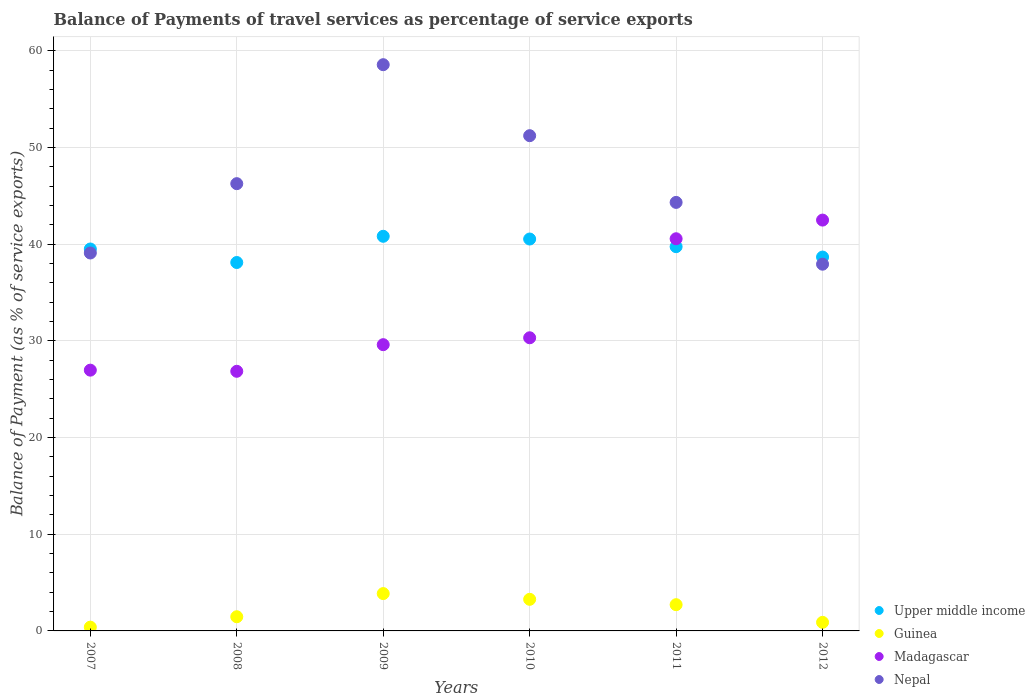What is the balance of payments of travel services in Madagascar in 2011?
Offer a terse response. 40.56. Across all years, what is the maximum balance of payments of travel services in Nepal?
Your response must be concise. 58.57. Across all years, what is the minimum balance of payments of travel services in Guinea?
Provide a succinct answer. 0.39. In which year was the balance of payments of travel services in Nepal maximum?
Your response must be concise. 2009. What is the total balance of payments of travel services in Upper middle income in the graph?
Provide a short and direct response. 237.39. What is the difference between the balance of payments of travel services in Upper middle income in 2010 and that in 2012?
Ensure brevity in your answer.  1.87. What is the difference between the balance of payments of travel services in Upper middle income in 2007 and the balance of payments of travel services in Madagascar in 2008?
Give a very brief answer. 12.65. What is the average balance of payments of travel services in Madagascar per year?
Give a very brief answer. 32.8. In the year 2010, what is the difference between the balance of payments of travel services in Guinea and balance of payments of travel services in Madagascar?
Give a very brief answer. -27.05. What is the ratio of the balance of payments of travel services in Madagascar in 2007 to that in 2009?
Provide a succinct answer. 0.91. Is the balance of payments of travel services in Madagascar in 2011 less than that in 2012?
Your answer should be very brief. Yes. Is the difference between the balance of payments of travel services in Guinea in 2008 and 2009 greater than the difference between the balance of payments of travel services in Madagascar in 2008 and 2009?
Give a very brief answer. Yes. What is the difference between the highest and the second highest balance of payments of travel services in Madagascar?
Provide a short and direct response. 1.93. What is the difference between the highest and the lowest balance of payments of travel services in Upper middle income?
Your answer should be very brief. 2.71. Is the sum of the balance of payments of travel services in Guinea in 2009 and 2012 greater than the maximum balance of payments of travel services in Nepal across all years?
Provide a succinct answer. No. Is it the case that in every year, the sum of the balance of payments of travel services in Upper middle income and balance of payments of travel services in Nepal  is greater than the sum of balance of payments of travel services in Guinea and balance of payments of travel services in Madagascar?
Your answer should be very brief. Yes. How many dotlines are there?
Provide a short and direct response. 4. How many years are there in the graph?
Ensure brevity in your answer.  6. Are the values on the major ticks of Y-axis written in scientific E-notation?
Your response must be concise. No. Does the graph contain grids?
Ensure brevity in your answer.  Yes. What is the title of the graph?
Your response must be concise. Balance of Payments of travel services as percentage of service exports. Does "Qatar" appear as one of the legend labels in the graph?
Ensure brevity in your answer.  No. What is the label or title of the X-axis?
Your answer should be very brief. Years. What is the label or title of the Y-axis?
Provide a succinct answer. Balance of Payment (as % of service exports). What is the Balance of Payment (as % of service exports) of Upper middle income in 2007?
Your answer should be compact. 39.51. What is the Balance of Payment (as % of service exports) in Guinea in 2007?
Give a very brief answer. 0.39. What is the Balance of Payment (as % of service exports) in Madagascar in 2007?
Give a very brief answer. 26.97. What is the Balance of Payment (as % of service exports) of Nepal in 2007?
Make the answer very short. 39.09. What is the Balance of Payment (as % of service exports) in Upper middle income in 2008?
Make the answer very short. 38.11. What is the Balance of Payment (as % of service exports) of Guinea in 2008?
Offer a terse response. 1.47. What is the Balance of Payment (as % of service exports) of Madagascar in 2008?
Keep it short and to the point. 26.86. What is the Balance of Payment (as % of service exports) of Nepal in 2008?
Keep it short and to the point. 46.26. What is the Balance of Payment (as % of service exports) in Upper middle income in 2009?
Your answer should be compact. 40.82. What is the Balance of Payment (as % of service exports) in Guinea in 2009?
Provide a short and direct response. 3.86. What is the Balance of Payment (as % of service exports) in Madagascar in 2009?
Offer a terse response. 29.61. What is the Balance of Payment (as % of service exports) in Nepal in 2009?
Provide a short and direct response. 58.57. What is the Balance of Payment (as % of service exports) of Upper middle income in 2010?
Provide a short and direct response. 40.54. What is the Balance of Payment (as % of service exports) of Guinea in 2010?
Offer a very short reply. 3.27. What is the Balance of Payment (as % of service exports) in Madagascar in 2010?
Give a very brief answer. 30.32. What is the Balance of Payment (as % of service exports) in Nepal in 2010?
Make the answer very short. 51.23. What is the Balance of Payment (as % of service exports) of Upper middle income in 2011?
Provide a succinct answer. 39.75. What is the Balance of Payment (as % of service exports) of Guinea in 2011?
Your answer should be compact. 2.71. What is the Balance of Payment (as % of service exports) of Madagascar in 2011?
Your answer should be very brief. 40.56. What is the Balance of Payment (as % of service exports) in Nepal in 2011?
Give a very brief answer. 44.33. What is the Balance of Payment (as % of service exports) in Upper middle income in 2012?
Your answer should be compact. 38.67. What is the Balance of Payment (as % of service exports) in Guinea in 2012?
Your answer should be compact. 0.89. What is the Balance of Payment (as % of service exports) of Madagascar in 2012?
Provide a succinct answer. 42.5. What is the Balance of Payment (as % of service exports) of Nepal in 2012?
Your response must be concise. 37.93. Across all years, what is the maximum Balance of Payment (as % of service exports) of Upper middle income?
Your response must be concise. 40.82. Across all years, what is the maximum Balance of Payment (as % of service exports) in Guinea?
Make the answer very short. 3.86. Across all years, what is the maximum Balance of Payment (as % of service exports) in Madagascar?
Your response must be concise. 42.5. Across all years, what is the maximum Balance of Payment (as % of service exports) in Nepal?
Offer a terse response. 58.57. Across all years, what is the minimum Balance of Payment (as % of service exports) in Upper middle income?
Provide a short and direct response. 38.11. Across all years, what is the minimum Balance of Payment (as % of service exports) of Guinea?
Provide a succinct answer. 0.39. Across all years, what is the minimum Balance of Payment (as % of service exports) of Madagascar?
Make the answer very short. 26.86. Across all years, what is the minimum Balance of Payment (as % of service exports) of Nepal?
Provide a short and direct response. 37.93. What is the total Balance of Payment (as % of service exports) in Upper middle income in the graph?
Provide a succinct answer. 237.39. What is the total Balance of Payment (as % of service exports) of Guinea in the graph?
Offer a terse response. 12.59. What is the total Balance of Payment (as % of service exports) of Madagascar in the graph?
Provide a succinct answer. 196.82. What is the total Balance of Payment (as % of service exports) in Nepal in the graph?
Provide a short and direct response. 277.41. What is the difference between the Balance of Payment (as % of service exports) of Upper middle income in 2007 and that in 2008?
Your response must be concise. 1.4. What is the difference between the Balance of Payment (as % of service exports) in Guinea in 2007 and that in 2008?
Your answer should be compact. -1.08. What is the difference between the Balance of Payment (as % of service exports) in Madagascar in 2007 and that in 2008?
Make the answer very short. 0.12. What is the difference between the Balance of Payment (as % of service exports) in Nepal in 2007 and that in 2008?
Provide a succinct answer. -7.17. What is the difference between the Balance of Payment (as % of service exports) in Upper middle income in 2007 and that in 2009?
Give a very brief answer. -1.31. What is the difference between the Balance of Payment (as % of service exports) in Guinea in 2007 and that in 2009?
Provide a short and direct response. -3.47. What is the difference between the Balance of Payment (as % of service exports) in Madagascar in 2007 and that in 2009?
Provide a short and direct response. -2.64. What is the difference between the Balance of Payment (as % of service exports) in Nepal in 2007 and that in 2009?
Offer a very short reply. -19.48. What is the difference between the Balance of Payment (as % of service exports) in Upper middle income in 2007 and that in 2010?
Your answer should be compact. -1.03. What is the difference between the Balance of Payment (as % of service exports) of Guinea in 2007 and that in 2010?
Give a very brief answer. -2.88. What is the difference between the Balance of Payment (as % of service exports) in Madagascar in 2007 and that in 2010?
Offer a terse response. -3.35. What is the difference between the Balance of Payment (as % of service exports) in Nepal in 2007 and that in 2010?
Make the answer very short. -12.13. What is the difference between the Balance of Payment (as % of service exports) in Upper middle income in 2007 and that in 2011?
Ensure brevity in your answer.  -0.24. What is the difference between the Balance of Payment (as % of service exports) in Guinea in 2007 and that in 2011?
Give a very brief answer. -2.32. What is the difference between the Balance of Payment (as % of service exports) in Madagascar in 2007 and that in 2011?
Provide a succinct answer. -13.59. What is the difference between the Balance of Payment (as % of service exports) in Nepal in 2007 and that in 2011?
Provide a succinct answer. -5.23. What is the difference between the Balance of Payment (as % of service exports) of Upper middle income in 2007 and that in 2012?
Make the answer very short. 0.83. What is the difference between the Balance of Payment (as % of service exports) of Guinea in 2007 and that in 2012?
Offer a terse response. -0.5. What is the difference between the Balance of Payment (as % of service exports) in Madagascar in 2007 and that in 2012?
Provide a succinct answer. -15.52. What is the difference between the Balance of Payment (as % of service exports) of Nepal in 2007 and that in 2012?
Offer a very short reply. 1.16. What is the difference between the Balance of Payment (as % of service exports) of Upper middle income in 2008 and that in 2009?
Offer a terse response. -2.71. What is the difference between the Balance of Payment (as % of service exports) in Guinea in 2008 and that in 2009?
Ensure brevity in your answer.  -2.39. What is the difference between the Balance of Payment (as % of service exports) in Madagascar in 2008 and that in 2009?
Your answer should be compact. -2.75. What is the difference between the Balance of Payment (as % of service exports) of Nepal in 2008 and that in 2009?
Provide a short and direct response. -12.31. What is the difference between the Balance of Payment (as % of service exports) of Upper middle income in 2008 and that in 2010?
Your response must be concise. -2.43. What is the difference between the Balance of Payment (as % of service exports) in Guinea in 2008 and that in 2010?
Your response must be concise. -1.8. What is the difference between the Balance of Payment (as % of service exports) of Madagascar in 2008 and that in 2010?
Keep it short and to the point. -3.47. What is the difference between the Balance of Payment (as % of service exports) in Nepal in 2008 and that in 2010?
Provide a short and direct response. -4.96. What is the difference between the Balance of Payment (as % of service exports) of Upper middle income in 2008 and that in 2011?
Give a very brief answer. -1.64. What is the difference between the Balance of Payment (as % of service exports) in Guinea in 2008 and that in 2011?
Offer a terse response. -1.25. What is the difference between the Balance of Payment (as % of service exports) in Madagascar in 2008 and that in 2011?
Provide a succinct answer. -13.71. What is the difference between the Balance of Payment (as % of service exports) of Nepal in 2008 and that in 2011?
Offer a very short reply. 1.94. What is the difference between the Balance of Payment (as % of service exports) of Upper middle income in 2008 and that in 2012?
Your response must be concise. -0.56. What is the difference between the Balance of Payment (as % of service exports) of Guinea in 2008 and that in 2012?
Give a very brief answer. 0.58. What is the difference between the Balance of Payment (as % of service exports) of Madagascar in 2008 and that in 2012?
Ensure brevity in your answer.  -15.64. What is the difference between the Balance of Payment (as % of service exports) in Nepal in 2008 and that in 2012?
Ensure brevity in your answer.  8.33. What is the difference between the Balance of Payment (as % of service exports) in Upper middle income in 2009 and that in 2010?
Provide a short and direct response. 0.28. What is the difference between the Balance of Payment (as % of service exports) in Guinea in 2009 and that in 2010?
Your response must be concise. 0.59. What is the difference between the Balance of Payment (as % of service exports) in Madagascar in 2009 and that in 2010?
Offer a very short reply. -0.71. What is the difference between the Balance of Payment (as % of service exports) of Nepal in 2009 and that in 2010?
Your response must be concise. 7.34. What is the difference between the Balance of Payment (as % of service exports) in Upper middle income in 2009 and that in 2011?
Your response must be concise. 1.07. What is the difference between the Balance of Payment (as % of service exports) in Guinea in 2009 and that in 2011?
Offer a terse response. 1.15. What is the difference between the Balance of Payment (as % of service exports) of Madagascar in 2009 and that in 2011?
Your answer should be very brief. -10.96. What is the difference between the Balance of Payment (as % of service exports) in Nepal in 2009 and that in 2011?
Make the answer very short. 14.24. What is the difference between the Balance of Payment (as % of service exports) in Upper middle income in 2009 and that in 2012?
Ensure brevity in your answer.  2.15. What is the difference between the Balance of Payment (as % of service exports) in Guinea in 2009 and that in 2012?
Give a very brief answer. 2.98. What is the difference between the Balance of Payment (as % of service exports) of Madagascar in 2009 and that in 2012?
Provide a succinct answer. -12.89. What is the difference between the Balance of Payment (as % of service exports) of Nepal in 2009 and that in 2012?
Your response must be concise. 20.64. What is the difference between the Balance of Payment (as % of service exports) in Upper middle income in 2010 and that in 2011?
Your answer should be compact. 0.79. What is the difference between the Balance of Payment (as % of service exports) in Guinea in 2010 and that in 2011?
Offer a terse response. 0.55. What is the difference between the Balance of Payment (as % of service exports) in Madagascar in 2010 and that in 2011?
Offer a very short reply. -10.24. What is the difference between the Balance of Payment (as % of service exports) of Nepal in 2010 and that in 2011?
Offer a terse response. 6.9. What is the difference between the Balance of Payment (as % of service exports) in Upper middle income in 2010 and that in 2012?
Keep it short and to the point. 1.87. What is the difference between the Balance of Payment (as % of service exports) in Guinea in 2010 and that in 2012?
Provide a succinct answer. 2.38. What is the difference between the Balance of Payment (as % of service exports) of Madagascar in 2010 and that in 2012?
Your response must be concise. -12.17. What is the difference between the Balance of Payment (as % of service exports) in Nepal in 2010 and that in 2012?
Offer a terse response. 13.29. What is the difference between the Balance of Payment (as % of service exports) in Upper middle income in 2011 and that in 2012?
Ensure brevity in your answer.  1.07. What is the difference between the Balance of Payment (as % of service exports) in Guinea in 2011 and that in 2012?
Offer a very short reply. 1.83. What is the difference between the Balance of Payment (as % of service exports) in Madagascar in 2011 and that in 2012?
Provide a succinct answer. -1.93. What is the difference between the Balance of Payment (as % of service exports) in Nepal in 2011 and that in 2012?
Your response must be concise. 6.39. What is the difference between the Balance of Payment (as % of service exports) in Upper middle income in 2007 and the Balance of Payment (as % of service exports) in Guinea in 2008?
Keep it short and to the point. 38.04. What is the difference between the Balance of Payment (as % of service exports) in Upper middle income in 2007 and the Balance of Payment (as % of service exports) in Madagascar in 2008?
Your answer should be very brief. 12.65. What is the difference between the Balance of Payment (as % of service exports) in Upper middle income in 2007 and the Balance of Payment (as % of service exports) in Nepal in 2008?
Give a very brief answer. -6.76. What is the difference between the Balance of Payment (as % of service exports) of Guinea in 2007 and the Balance of Payment (as % of service exports) of Madagascar in 2008?
Ensure brevity in your answer.  -26.46. What is the difference between the Balance of Payment (as % of service exports) in Guinea in 2007 and the Balance of Payment (as % of service exports) in Nepal in 2008?
Give a very brief answer. -45.87. What is the difference between the Balance of Payment (as % of service exports) of Madagascar in 2007 and the Balance of Payment (as % of service exports) of Nepal in 2008?
Make the answer very short. -19.29. What is the difference between the Balance of Payment (as % of service exports) of Upper middle income in 2007 and the Balance of Payment (as % of service exports) of Guinea in 2009?
Offer a very short reply. 35.64. What is the difference between the Balance of Payment (as % of service exports) in Upper middle income in 2007 and the Balance of Payment (as % of service exports) in Madagascar in 2009?
Your answer should be very brief. 9.9. What is the difference between the Balance of Payment (as % of service exports) of Upper middle income in 2007 and the Balance of Payment (as % of service exports) of Nepal in 2009?
Offer a terse response. -19.06. What is the difference between the Balance of Payment (as % of service exports) of Guinea in 2007 and the Balance of Payment (as % of service exports) of Madagascar in 2009?
Offer a terse response. -29.22. What is the difference between the Balance of Payment (as % of service exports) in Guinea in 2007 and the Balance of Payment (as % of service exports) in Nepal in 2009?
Your response must be concise. -58.18. What is the difference between the Balance of Payment (as % of service exports) of Madagascar in 2007 and the Balance of Payment (as % of service exports) of Nepal in 2009?
Offer a terse response. -31.6. What is the difference between the Balance of Payment (as % of service exports) of Upper middle income in 2007 and the Balance of Payment (as % of service exports) of Guinea in 2010?
Ensure brevity in your answer.  36.24. What is the difference between the Balance of Payment (as % of service exports) in Upper middle income in 2007 and the Balance of Payment (as % of service exports) in Madagascar in 2010?
Offer a terse response. 9.18. What is the difference between the Balance of Payment (as % of service exports) in Upper middle income in 2007 and the Balance of Payment (as % of service exports) in Nepal in 2010?
Make the answer very short. -11.72. What is the difference between the Balance of Payment (as % of service exports) of Guinea in 2007 and the Balance of Payment (as % of service exports) of Madagascar in 2010?
Provide a succinct answer. -29.93. What is the difference between the Balance of Payment (as % of service exports) in Guinea in 2007 and the Balance of Payment (as % of service exports) in Nepal in 2010?
Your answer should be very brief. -50.84. What is the difference between the Balance of Payment (as % of service exports) in Madagascar in 2007 and the Balance of Payment (as % of service exports) in Nepal in 2010?
Provide a short and direct response. -24.25. What is the difference between the Balance of Payment (as % of service exports) of Upper middle income in 2007 and the Balance of Payment (as % of service exports) of Guinea in 2011?
Offer a very short reply. 36.79. What is the difference between the Balance of Payment (as % of service exports) in Upper middle income in 2007 and the Balance of Payment (as % of service exports) in Madagascar in 2011?
Ensure brevity in your answer.  -1.06. What is the difference between the Balance of Payment (as % of service exports) of Upper middle income in 2007 and the Balance of Payment (as % of service exports) of Nepal in 2011?
Your answer should be very brief. -4.82. What is the difference between the Balance of Payment (as % of service exports) of Guinea in 2007 and the Balance of Payment (as % of service exports) of Madagascar in 2011?
Ensure brevity in your answer.  -40.17. What is the difference between the Balance of Payment (as % of service exports) in Guinea in 2007 and the Balance of Payment (as % of service exports) in Nepal in 2011?
Make the answer very short. -43.94. What is the difference between the Balance of Payment (as % of service exports) of Madagascar in 2007 and the Balance of Payment (as % of service exports) of Nepal in 2011?
Make the answer very short. -17.35. What is the difference between the Balance of Payment (as % of service exports) in Upper middle income in 2007 and the Balance of Payment (as % of service exports) in Guinea in 2012?
Keep it short and to the point. 38.62. What is the difference between the Balance of Payment (as % of service exports) of Upper middle income in 2007 and the Balance of Payment (as % of service exports) of Madagascar in 2012?
Your answer should be very brief. -2.99. What is the difference between the Balance of Payment (as % of service exports) of Upper middle income in 2007 and the Balance of Payment (as % of service exports) of Nepal in 2012?
Keep it short and to the point. 1.57. What is the difference between the Balance of Payment (as % of service exports) in Guinea in 2007 and the Balance of Payment (as % of service exports) in Madagascar in 2012?
Provide a short and direct response. -42.11. What is the difference between the Balance of Payment (as % of service exports) of Guinea in 2007 and the Balance of Payment (as % of service exports) of Nepal in 2012?
Offer a terse response. -37.54. What is the difference between the Balance of Payment (as % of service exports) of Madagascar in 2007 and the Balance of Payment (as % of service exports) of Nepal in 2012?
Provide a short and direct response. -10.96. What is the difference between the Balance of Payment (as % of service exports) in Upper middle income in 2008 and the Balance of Payment (as % of service exports) in Guinea in 2009?
Make the answer very short. 34.25. What is the difference between the Balance of Payment (as % of service exports) in Upper middle income in 2008 and the Balance of Payment (as % of service exports) in Madagascar in 2009?
Give a very brief answer. 8.5. What is the difference between the Balance of Payment (as % of service exports) in Upper middle income in 2008 and the Balance of Payment (as % of service exports) in Nepal in 2009?
Ensure brevity in your answer.  -20.46. What is the difference between the Balance of Payment (as % of service exports) in Guinea in 2008 and the Balance of Payment (as % of service exports) in Madagascar in 2009?
Offer a terse response. -28.14. What is the difference between the Balance of Payment (as % of service exports) of Guinea in 2008 and the Balance of Payment (as % of service exports) of Nepal in 2009?
Provide a short and direct response. -57.1. What is the difference between the Balance of Payment (as % of service exports) in Madagascar in 2008 and the Balance of Payment (as % of service exports) in Nepal in 2009?
Provide a succinct answer. -31.71. What is the difference between the Balance of Payment (as % of service exports) of Upper middle income in 2008 and the Balance of Payment (as % of service exports) of Guinea in 2010?
Your answer should be compact. 34.84. What is the difference between the Balance of Payment (as % of service exports) of Upper middle income in 2008 and the Balance of Payment (as % of service exports) of Madagascar in 2010?
Your answer should be very brief. 7.79. What is the difference between the Balance of Payment (as % of service exports) of Upper middle income in 2008 and the Balance of Payment (as % of service exports) of Nepal in 2010?
Keep it short and to the point. -13.12. What is the difference between the Balance of Payment (as % of service exports) in Guinea in 2008 and the Balance of Payment (as % of service exports) in Madagascar in 2010?
Your answer should be compact. -28.85. What is the difference between the Balance of Payment (as % of service exports) of Guinea in 2008 and the Balance of Payment (as % of service exports) of Nepal in 2010?
Give a very brief answer. -49.76. What is the difference between the Balance of Payment (as % of service exports) in Madagascar in 2008 and the Balance of Payment (as % of service exports) in Nepal in 2010?
Provide a succinct answer. -24.37. What is the difference between the Balance of Payment (as % of service exports) in Upper middle income in 2008 and the Balance of Payment (as % of service exports) in Guinea in 2011?
Your response must be concise. 35.39. What is the difference between the Balance of Payment (as % of service exports) in Upper middle income in 2008 and the Balance of Payment (as % of service exports) in Madagascar in 2011?
Provide a succinct answer. -2.46. What is the difference between the Balance of Payment (as % of service exports) of Upper middle income in 2008 and the Balance of Payment (as % of service exports) of Nepal in 2011?
Offer a terse response. -6.22. What is the difference between the Balance of Payment (as % of service exports) of Guinea in 2008 and the Balance of Payment (as % of service exports) of Madagascar in 2011?
Provide a succinct answer. -39.1. What is the difference between the Balance of Payment (as % of service exports) of Guinea in 2008 and the Balance of Payment (as % of service exports) of Nepal in 2011?
Make the answer very short. -42.86. What is the difference between the Balance of Payment (as % of service exports) in Madagascar in 2008 and the Balance of Payment (as % of service exports) in Nepal in 2011?
Make the answer very short. -17.47. What is the difference between the Balance of Payment (as % of service exports) in Upper middle income in 2008 and the Balance of Payment (as % of service exports) in Guinea in 2012?
Your answer should be compact. 37.22. What is the difference between the Balance of Payment (as % of service exports) of Upper middle income in 2008 and the Balance of Payment (as % of service exports) of Madagascar in 2012?
Offer a very short reply. -4.39. What is the difference between the Balance of Payment (as % of service exports) of Upper middle income in 2008 and the Balance of Payment (as % of service exports) of Nepal in 2012?
Your response must be concise. 0.17. What is the difference between the Balance of Payment (as % of service exports) in Guinea in 2008 and the Balance of Payment (as % of service exports) in Madagascar in 2012?
Keep it short and to the point. -41.03. What is the difference between the Balance of Payment (as % of service exports) in Guinea in 2008 and the Balance of Payment (as % of service exports) in Nepal in 2012?
Ensure brevity in your answer.  -36.47. What is the difference between the Balance of Payment (as % of service exports) of Madagascar in 2008 and the Balance of Payment (as % of service exports) of Nepal in 2012?
Offer a very short reply. -11.08. What is the difference between the Balance of Payment (as % of service exports) in Upper middle income in 2009 and the Balance of Payment (as % of service exports) in Guinea in 2010?
Your answer should be very brief. 37.55. What is the difference between the Balance of Payment (as % of service exports) in Upper middle income in 2009 and the Balance of Payment (as % of service exports) in Madagascar in 2010?
Your response must be concise. 10.5. What is the difference between the Balance of Payment (as % of service exports) of Upper middle income in 2009 and the Balance of Payment (as % of service exports) of Nepal in 2010?
Your answer should be compact. -10.41. What is the difference between the Balance of Payment (as % of service exports) in Guinea in 2009 and the Balance of Payment (as % of service exports) in Madagascar in 2010?
Give a very brief answer. -26.46. What is the difference between the Balance of Payment (as % of service exports) in Guinea in 2009 and the Balance of Payment (as % of service exports) in Nepal in 2010?
Your response must be concise. -47.36. What is the difference between the Balance of Payment (as % of service exports) of Madagascar in 2009 and the Balance of Payment (as % of service exports) of Nepal in 2010?
Offer a very short reply. -21.62. What is the difference between the Balance of Payment (as % of service exports) of Upper middle income in 2009 and the Balance of Payment (as % of service exports) of Guinea in 2011?
Your answer should be compact. 38.11. What is the difference between the Balance of Payment (as % of service exports) in Upper middle income in 2009 and the Balance of Payment (as % of service exports) in Madagascar in 2011?
Make the answer very short. 0.26. What is the difference between the Balance of Payment (as % of service exports) of Upper middle income in 2009 and the Balance of Payment (as % of service exports) of Nepal in 2011?
Offer a terse response. -3.51. What is the difference between the Balance of Payment (as % of service exports) of Guinea in 2009 and the Balance of Payment (as % of service exports) of Madagascar in 2011?
Your answer should be compact. -36.7. What is the difference between the Balance of Payment (as % of service exports) of Guinea in 2009 and the Balance of Payment (as % of service exports) of Nepal in 2011?
Your answer should be very brief. -40.46. What is the difference between the Balance of Payment (as % of service exports) of Madagascar in 2009 and the Balance of Payment (as % of service exports) of Nepal in 2011?
Offer a terse response. -14.72. What is the difference between the Balance of Payment (as % of service exports) of Upper middle income in 2009 and the Balance of Payment (as % of service exports) of Guinea in 2012?
Offer a terse response. 39.93. What is the difference between the Balance of Payment (as % of service exports) in Upper middle income in 2009 and the Balance of Payment (as % of service exports) in Madagascar in 2012?
Your answer should be compact. -1.68. What is the difference between the Balance of Payment (as % of service exports) in Upper middle income in 2009 and the Balance of Payment (as % of service exports) in Nepal in 2012?
Ensure brevity in your answer.  2.89. What is the difference between the Balance of Payment (as % of service exports) of Guinea in 2009 and the Balance of Payment (as % of service exports) of Madagascar in 2012?
Give a very brief answer. -38.63. What is the difference between the Balance of Payment (as % of service exports) of Guinea in 2009 and the Balance of Payment (as % of service exports) of Nepal in 2012?
Your answer should be very brief. -34.07. What is the difference between the Balance of Payment (as % of service exports) in Madagascar in 2009 and the Balance of Payment (as % of service exports) in Nepal in 2012?
Your answer should be very brief. -8.33. What is the difference between the Balance of Payment (as % of service exports) of Upper middle income in 2010 and the Balance of Payment (as % of service exports) of Guinea in 2011?
Your response must be concise. 37.82. What is the difference between the Balance of Payment (as % of service exports) in Upper middle income in 2010 and the Balance of Payment (as % of service exports) in Madagascar in 2011?
Keep it short and to the point. -0.03. What is the difference between the Balance of Payment (as % of service exports) of Upper middle income in 2010 and the Balance of Payment (as % of service exports) of Nepal in 2011?
Provide a succinct answer. -3.79. What is the difference between the Balance of Payment (as % of service exports) in Guinea in 2010 and the Balance of Payment (as % of service exports) in Madagascar in 2011?
Provide a succinct answer. -37.3. What is the difference between the Balance of Payment (as % of service exports) in Guinea in 2010 and the Balance of Payment (as % of service exports) in Nepal in 2011?
Provide a succinct answer. -41.06. What is the difference between the Balance of Payment (as % of service exports) of Madagascar in 2010 and the Balance of Payment (as % of service exports) of Nepal in 2011?
Provide a short and direct response. -14. What is the difference between the Balance of Payment (as % of service exports) of Upper middle income in 2010 and the Balance of Payment (as % of service exports) of Guinea in 2012?
Offer a very short reply. 39.65. What is the difference between the Balance of Payment (as % of service exports) in Upper middle income in 2010 and the Balance of Payment (as % of service exports) in Madagascar in 2012?
Provide a short and direct response. -1.96. What is the difference between the Balance of Payment (as % of service exports) in Upper middle income in 2010 and the Balance of Payment (as % of service exports) in Nepal in 2012?
Provide a short and direct response. 2.6. What is the difference between the Balance of Payment (as % of service exports) of Guinea in 2010 and the Balance of Payment (as % of service exports) of Madagascar in 2012?
Your response must be concise. -39.23. What is the difference between the Balance of Payment (as % of service exports) in Guinea in 2010 and the Balance of Payment (as % of service exports) in Nepal in 2012?
Your answer should be very brief. -34.67. What is the difference between the Balance of Payment (as % of service exports) in Madagascar in 2010 and the Balance of Payment (as % of service exports) in Nepal in 2012?
Give a very brief answer. -7.61. What is the difference between the Balance of Payment (as % of service exports) of Upper middle income in 2011 and the Balance of Payment (as % of service exports) of Guinea in 2012?
Make the answer very short. 38.86. What is the difference between the Balance of Payment (as % of service exports) in Upper middle income in 2011 and the Balance of Payment (as % of service exports) in Madagascar in 2012?
Your answer should be very brief. -2.75. What is the difference between the Balance of Payment (as % of service exports) in Upper middle income in 2011 and the Balance of Payment (as % of service exports) in Nepal in 2012?
Provide a short and direct response. 1.81. What is the difference between the Balance of Payment (as % of service exports) of Guinea in 2011 and the Balance of Payment (as % of service exports) of Madagascar in 2012?
Your response must be concise. -39.78. What is the difference between the Balance of Payment (as % of service exports) in Guinea in 2011 and the Balance of Payment (as % of service exports) in Nepal in 2012?
Your response must be concise. -35.22. What is the difference between the Balance of Payment (as % of service exports) in Madagascar in 2011 and the Balance of Payment (as % of service exports) in Nepal in 2012?
Your response must be concise. 2.63. What is the average Balance of Payment (as % of service exports) of Upper middle income per year?
Your answer should be very brief. 39.56. What is the average Balance of Payment (as % of service exports) in Guinea per year?
Your answer should be compact. 2.1. What is the average Balance of Payment (as % of service exports) in Madagascar per year?
Provide a short and direct response. 32.8. What is the average Balance of Payment (as % of service exports) of Nepal per year?
Make the answer very short. 46.24. In the year 2007, what is the difference between the Balance of Payment (as % of service exports) in Upper middle income and Balance of Payment (as % of service exports) in Guinea?
Offer a very short reply. 39.12. In the year 2007, what is the difference between the Balance of Payment (as % of service exports) in Upper middle income and Balance of Payment (as % of service exports) in Madagascar?
Give a very brief answer. 12.53. In the year 2007, what is the difference between the Balance of Payment (as % of service exports) of Upper middle income and Balance of Payment (as % of service exports) of Nepal?
Provide a succinct answer. 0.41. In the year 2007, what is the difference between the Balance of Payment (as % of service exports) in Guinea and Balance of Payment (as % of service exports) in Madagascar?
Make the answer very short. -26.58. In the year 2007, what is the difference between the Balance of Payment (as % of service exports) in Guinea and Balance of Payment (as % of service exports) in Nepal?
Offer a very short reply. -38.7. In the year 2007, what is the difference between the Balance of Payment (as % of service exports) of Madagascar and Balance of Payment (as % of service exports) of Nepal?
Your answer should be compact. -12.12. In the year 2008, what is the difference between the Balance of Payment (as % of service exports) of Upper middle income and Balance of Payment (as % of service exports) of Guinea?
Give a very brief answer. 36.64. In the year 2008, what is the difference between the Balance of Payment (as % of service exports) in Upper middle income and Balance of Payment (as % of service exports) in Madagascar?
Give a very brief answer. 11.25. In the year 2008, what is the difference between the Balance of Payment (as % of service exports) in Upper middle income and Balance of Payment (as % of service exports) in Nepal?
Your response must be concise. -8.16. In the year 2008, what is the difference between the Balance of Payment (as % of service exports) in Guinea and Balance of Payment (as % of service exports) in Madagascar?
Ensure brevity in your answer.  -25.39. In the year 2008, what is the difference between the Balance of Payment (as % of service exports) of Guinea and Balance of Payment (as % of service exports) of Nepal?
Your answer should be compact. -44.8. In the year 2008, what is the difference between the Balance of Payment (as % of service exports) of Madagascar and Balance of Payment (as % of service exports) of Nepal?
Give a very brief answer. -19.41. In the year 2009, what is the difference between the Balance of Payment (as % of service exports) in Upper middle income and Balance of Payment (as % of service exports) in Guinea?
Your response must be concise. 36.96. In the year 2009, what is the difference between the Balance of Payment (as % of service exports) of Upper middle income and Balance of Payment (as % of service exports) of Madagascar?
Your response must be concise. 11.21. In the year 2009, what is the difference between the Balance of Payment (as % of service exports) in Upper middle income and Balance of Payment (as % of service exports) in Nepal?
Provide a short and direct response. -17.75. In the year 2009, what is the difference between the Balance of Payment (as % of service exports) in Guinea and Balance of Payment (as % of service exports) in Madagascar?
Provide a succinct answer. -25.75. In the year 2009, what is the difference between the Balance of Payment (as % of service exports) in Guinea and Balance of Payment (as % of service exports) in Nepal?
Give a very brief answer. -54.71. In the year 2009, what is the difference between the Balance of Payment (as % of service exports) of Madagascar and Balance of Payment (as % of service exports) of Nepal?
Provide a short and direct response. -28.96. In the year 2010, what is the difference between the Balance of Payment (as % of service exports) in Upper middle income and Balance of Payment (as % of service exports) in Guinea?
Provide a succinct answer. 37.27. In the year 2010, what is the difference between the Balance of Payment (as % of service exports) in Upper middle income and Balance of Payment (as % of service exports) in Madagascar?
Offer a very short reply. 10.21. In the year 2010, what is the difference between the Balance of Payment (as % of service exports) in Upper middle income and Balance of Payment (as % of service exports) in Nepal?
Keep it short and to the point. -10.69. In the year 2010, what is the difference between the Balance of Payment (as % of service exports) in Guinea and Balance of Payment (as % of service exports) in Madagascar?
Provide a succinct answer. -27.05. In the year 2010, what is the difference between the Balance of Payment (as % of service exports) of Guinea and Balance of Payment (as % of service exports) of Nepal?
Offer a terse response. -47.96. In the year 2010, what is the difference between the Balance of Payment (as % of service exports) in Madagascar and Balance of Payment (as % of service exports) in Nepal?
Provide a short and direct response. -20.9. In the year 2011, what is the difference between the Balance of Payment (as % of service exports) in Upper middle income and Balance of Payment (as % of service exports) in Guinea?
Provide a succinct answer. 37.03. In the year 2011, what is the difference between the Balance of Payment (as % of service exports) in Upper middle income and Balance of Payment (as % of service exports) in Madagascar?
Your answer should be very brief. -0.82. In the year 2011, what is the difference between the Balance of Payment (as % of service exports) in Upper middle income and Balance of Payment (as % of service exports) in Nepal?
Ensure brevity in your answer.  -4.58. In the year 2011, what is the difference between the Balance of Payment (as % of service exports) of Guinea and Balance of Payment (as % of service exports) of Madagascar?
Provide a succinct answer. -37.85. In the year 2011, what is the difference between the Balance of Payment (as % of service exports) of Guinea and Balance of Payment (as % of service exports) of Nepal?
Your answer should be compact. -41.61. In the year 2011, what is the difference between the Balance of Payment (as % of service exports) of Madagascar and Balance of Payment (as % of service exports) of Nepal?
Your answer should be compact. -3.76. In the year 2012, what is the difference between the Balance of Payment (as % of service exports) of Upper middle income and Balance of Payment (as % of service exports) of Guinea?
Ensure brevity in your answer.  37.79. In the year 2012, what is the difference between the Balance of Payment (as % of service exports) in Upper middle income and Balance of Payment (as % of service exports) in Madagascar?
Ensure brevity in your answer.  -3.82. In the year 2012, what is the difference between the Balance of Payment (as % of service exports) in Upper middle income and Balance of Payment (as % of service exports) in Nepal?
Ensure brevity in your answer.  0.74. In the year 2012, what is the difference between the Balance of Payment (as % of service exports) of Guinea and Balance of Payment (as % of service exports) of Madagascar?
Offer a very short reply. -41.61. In the year 2012, what is the difference between the Balance of Payment (as % of service exports) of Guinea and Balance of Payment (as % of service exports) of Nepal?
Give a very brief answer. -37.05. In the year 2012, what is the difference between the Balance of Payment (as % of service exports) of Madagascar and Balance of Payment (as % of service exports) of Nepal?
Provide a succinct answer. 4.56. What is the ratio of the Balance of Payment (as % of service exports) in Upper middle income in 2007 to that in 2008?
Offer a very short reply. 1.04. What is the ratio of the Balance of Payment (as % of service exports) of Guinea in 2007 to that in 2008?
Your answer should be compact. 0.27. What is the ratio of the Balance of Payment (as % of service exports) in Madagascar in 2007 to that in 2008?
Your answer should be very brief. 1. What is the ratio of the Balance of Payment (as % of service exports) of Nepal in 2007 to that in 2008?
Make the answer very short. 0.84. What is the ratio of the Balance of Payment (as % of service exports) in Upper middle income in 2007 to that in 2009?
Make the answer very short. 0.97. What is the ratio of the Balance of Payment (as % of service exports) of Guinea in 2007 to that in 2009?
Give a very brief answer. 0.1. What is the ratio of the Balance of Payment (as % of service exports) in Madagascar in 2007 to that in 2009?
Make the answer very short. 0.91. What is the ratio of the Balance of Payment (as % of service exports) of Nepal in 2007 to that in 2009?
Offer a terse response. 0.67. What is the ratio of the Balance of Payment (as % of service exports) in Upper middle income in 2007 to that in 2010?
Provide a short and direct response. 0.97. What is the ratio of the Balance of Payment (as % of service exports) of Guinea in 2007 to that in 2010?
Ensure brevity in your answer.  0.12. What is the ratio of the Balance of Payment (as % of service exports) of Madagascar in 2007 to that in 2010?
Offer a very short reply. 0.89. What is the ratio of the Balance of Payment (as % of service exports) in Nepal in 2007 to that in 2010?
Your answer should be very brief. 0.76. What is the ratio of the Balance of Payment (as % of service exports) of Upper middle income in 2007 to that in 2011?
Your answer should be very brief. 0.99. What is the ratio of the Balance of Payment (as % of service exports) of Guinea in 2007 to that in 2011?
Offer a terse response. 0.14. What is the ratio of the Balance of Payment (as % of service exports) in Madagascar in 2007 to that in 2011?
Offer a terse response. 0.66. What is the ratio of the Balance of Payment (as % of service exports) in Nepal in 2007 to that in 2011?
Keep it short and to the point. 0.88. What is the ratio of the Balance of Payment (as % of service exports) in Upper middle income in 2007 to that in 2012?
Offer a very short reply. 1.02. What is the ratio of the Balance of Payment (as % of service exports) in Guinea in 2007 to that in 2012?
Provide a succinct answer. 0.44. What is the ratio of the Balance of Payment (as % of service exports) of Madagascar in 2007 to that in 2012?
Make the answer very short. 0.63. What is the ratio of the Balance of Payment (as % of service exports) in Nepal in 2007 to that in 2012?
Offer a terse response. 1.03. What is the ratio of the Balance of Payment (as % of service exports) of Upper middle income in 2008 to that in 2009?
Ensure brevity in your answer.  0.93. What is the ratio of the Balance of Payment (as % of service exports) in Guinea in 2008 to that in 2009?
Offer a very short reply. 0.38. What is the ratio of the Balance of Payment (as % of service exports) in Madagascar in 2008 to that in 2009?
Provide a succinct answer. 0.91. What is the ratio of the Balance of Payment (as % of service exports) of Nepal in 2008 to that in 2009?
Provide a succinct answer. 0.79. What is the ratio of the Balance of Payment (as % of service exports) in Upper middle income in 2008 to that in 2010?
Offer a terse response. 0.94. What is the ratio of the Balance of Payment (as % of service exports) in Guinea in 2008 to that in 2010?
Make the answer very short. 0.45. What is the ratio of the Balance of Payment (as % of service exports) in Madagascar in 2008 to that in 2010?
Your response must be concise. 0.89. What is the ratio of the Balance of Payment (as % of service exports) in Nepal in 2008 to that in 2010?
Keep it short and to the point. 0.9. What is the ratio of the Balance of Payment (as % of service exports) of Upper middle income in 2008 to that in 2011?
Provide a short and direct response. 0.96. What is the ratio of the Balance of Payment (as % of service exports) in Guinea in 2008 to that in 2011?
Offer a very short reply. 0.54. What is the ratio of the Balance of Payment (as % of service exports) of Madagascar in 2008 to that in 2011?
Your response must be concise. 0.66. What is the ratio of the Balance of Payment (as % of service exports) of Nepal in 2008 to that in 2011?
Provide a succinct answer. 1.04. What is the ratio of the Balance of Payment (as % of service exports) of Upper middle income in 2008 to that in 2012?
Offer a terse response. 0.99. What is the ratio of the Balance of Payment (as % of service exports) of Guinea in 2008 to that in 2012?
Your answer should be very brief. 1.66. What is the ratio of the Balance of Payment (as % of service exports) of Madagascar in 2008 to that in 2012?
Provide a short and direct response. 0.63. What is the ratio of the Balance of Payment (as % of service exports) of Nepal in 2008 to that in 2012?
Your answer should be compact. 1.22. What is the ratio of the Balance of Payment (as % of service exports) in Guinea in 2009 to that in 2010?
Make the answer very short. 1.18. What is the ratio of the Balance of Payment (as % of service exports) of Madagascar in 2009 to that in 2010?
Your answer should be very brief. 0.98. What is the ratio of the Balance of Payment (as % of service exports) of Nepal in 2009 to that in 2010?
Ensure brevity in your answer.  1.14. What is the ratio of the Balance of Payment (as % of service exports) in Upper middle income in 2009 to that in 2011?
Provide a short and direct response. 1.03. What is the ratio of the Balance of Payment (as % of service exports) of Guinea in 2009 to that in 2011?
Ensure brevity in your answer.  1.42. What is the ratio of the Balance of Payment (as % of service exports) of Madagascar in 2009 to that in 2011?
Offer a terse response. 0.73. What is the ratio of the Balance of Payment (as % of service exports) of Nepal in 2009 to that in 2011?
Keep it short and to the point. 1.32. What is the ratio of the Balance of Payment (as % of service exports) in Upper middle income in 2009 to that in 2012?
Your answer should be compact. 1.06. What is the ratio of the Balance of Payment (as % of service exports) of Guinea in 2009 to that in 2012?
Provide a succinct answer. 4.36. What is the ratio of the Balance of Payment (as % of service exports) in Madagascar in 2009 to that in 2012?
Offer a very short reply. 0.7. What is the ratio of the Balance of Payment (as % of service exports) in Nepal in 2009 to that in 2012?
Offer a very short reply. 1.54. What is the ratio of the Balance of Payment (as % of service exports) in Upper middle income in 2010 to that in 2011?
Your answer should be compact. 1.02. What is the ratio of the Balance of Payment (as % of service exports) of Guinea in 2010 to that in 2011?
Ensure brevity in your answer.  1.2. What is the ratio of the Balance of Payment (as % of service exports) of Madagascar in 2010 to that in 2011?
Provide a short and direct response. 0.75. What is the ratio of the Balance of Payment (as % of service exports) in Nepal in 2010 to that in 2011?
Offer a very short reply. 1.16. What is the ratio of the Balance of Payment (as % of service exports) in Upper middle income in 2010 to that in 2012?
Your answer should be very brief. 1.05. What is the ratio of the Balance of Payment (as % of service exports) of Guinea in 2010 to that in 2012?
Provide a succinct answer. 3.69. What is the ratio of the Balance of Payment (as % of service exports) of Madagascar in 2010 to that in 2012?
Make the answer very short. 0.71. What is the ratio of the Balance of Payment (as % of service exports) in Nepal in 2010 to that in 2012?
Your answer should be very brief. 1.35. What is the ratio of the Balance of Payment (as % of service exports) in Upper middle income in 2011 to that in 2012?
Offer a very short reply. 1.03. What is the ratio of the Balance of Payment (as % of service exports) in Guinea in 2011 to that in 2012?
Give a very brief answer. 3.06. What is the ratio of the Balance of Payment (as % of service exports) of Madagascar in 2011 to that in 2012?
Keep it short and to the point. 0.95. What is the ratio of the Balance of Payment (as % of service exports) in Nepal in 2011 to that in 2012?
Your answer should be very brief. 1.17. What is the difference between the highest and the second highest Balance of Payment (as % of service exports) in Upper middle income?
Offer a terse response. 0.28. What is the difference between the highest and the second highest Balance of Payment (as % of service exports) of Guinea?
Your answer should be compact. 0.59. What is the difference between the highest and the second highest Balance of Payment (as % of service exports) in Madagascar?
Provide a short and direct response. 1.93. What is the difference between the highest and the second highest Balance of Payment (as % of service exports) of Nepal?
Ensure brevity in your answer.  7.34. What is the difference between the highest and the lowest Balance of Payment (as % of service exports) of Upper middle income?
Provide a succinct answer. 2.71. What is the difference between the highest and the lowest Balance of Payment (as % of service exports) of Guinea?
Offer a very short reply. 3.47. What is the difference between the highest and the lowest Balance of Payment (as % of service exports) of Madagascar?
Make the answer very short. 15.64. What is the difference between the highest and the lowest Balance of Payment (as % of service exports) in Nepal?
Provide a succinct answer. 20.64. 